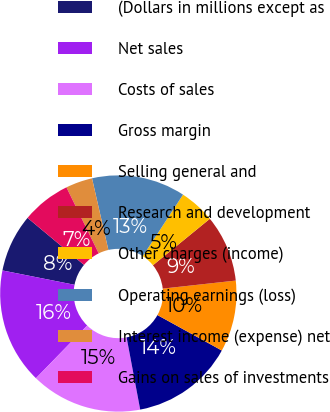<chart> <loc_0><loc_0><loc_500><loc_500><pie_chart><fcel>(Dollars in millions except as<fcel>Net sales<fcel>Costs of sales<fcel>Gross margin<fcel>Selling general and<fcel>Research and development<fcel>Other charges (income)<fcel>Operating earnings (loss)<fcel>Interest income (expense) net<fcel>Gains on sales of investments<nl><fcel>7.93%<fcel>15.85%<fcel>15.24%<fcel>14.02%<fcel>9.76%<fcel>9.15%<fcel>4.88%<fcel>12.8%<fcel>3.66%<fcel>6.71%<nl></chart> 